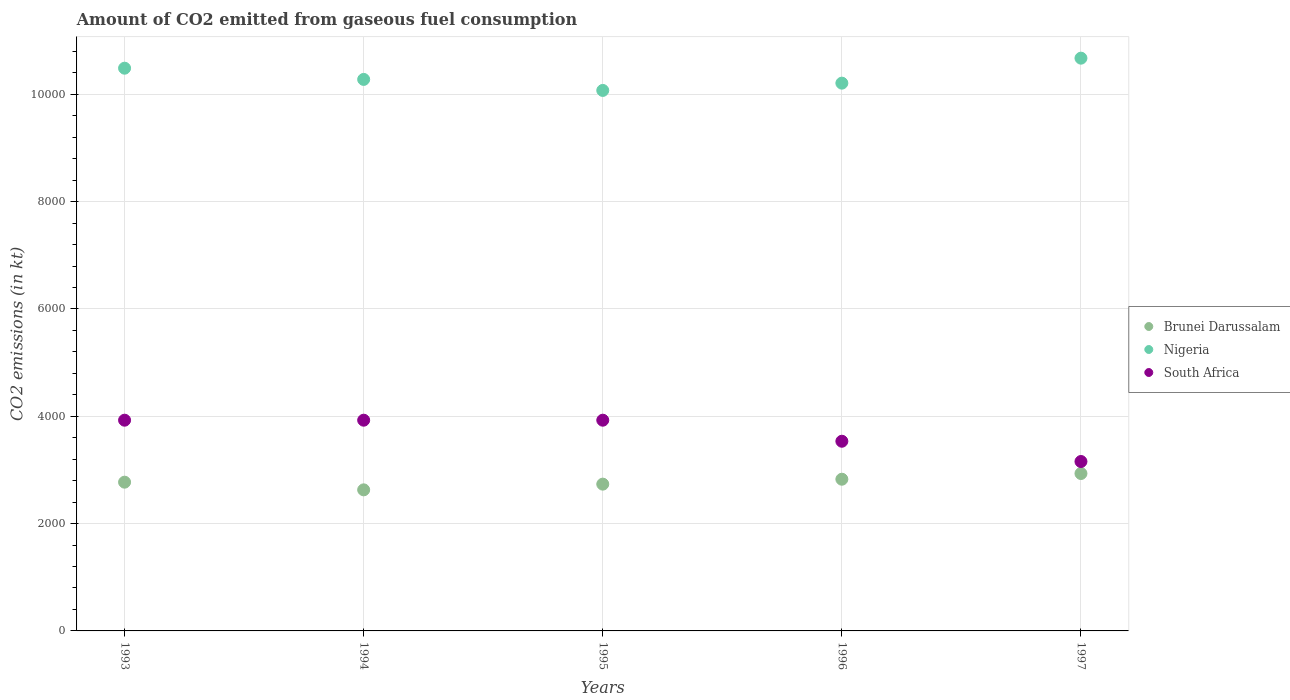How many different coloured dotlines are there?
Ensure brevity in your answer.  3. Is the number of dotlines equal to the number of legend labels?
Your answer should be compact. Yes. What is the amount of CO2 emitted in Nigeria in 1997?
Offer a very short reply. 1.07e+04. Across all years, what is the maximum amount of CO2 emitted in Nigeria?
Offer a very short reply. 1.07e+04. Across all years, what is the minimum amount of CO2 emitted in Nigeria?
Provide a succinct answer. 1.01e+04. What is the total amount of CO2 emitted in South Africa in the graph?
Offer a very short reply. 1.85e+04. What is the difference between the amount of CO2 emitted in South Africa in 1995 and that in 1997?
Make the answer very short. 770.07. What is the difference between the amount of CO2 emitted in Nigeria in 1994 and the amount of CO2 emitted in South Africa in 1996?
Your answer should be very brief. 6743.61. What is the average amount of CO2 emitted in South Africa per year?
Make the answer very short. 3694.87. In the year 1994, what is the difference between the amount of CO2 emitted in Nigeria and amount of CO2 emitted in South Africa?
Provide a succinct answer. 6351.24. What is the ratio of the amount of CO2 emitted in Brunei Darussalam in 1994 to that in 1996?
Offer a very short reply. 0.93. Is the difference between the amount of CO2 emitted in Nigeria in 1993 and 1996 greater than the difference between the amount of CO2 emitted in South Africa in 1993 and 1996?
Provide a succinct answer. No. What is the difference between the highest and the second highest amount of CO2 emitted in Nigeria?
Make the answer very short. 187.02. What is the difference between the highest and the lowest amount of CO2 emitted in Brunei Darussalam?
Ensure brevity in your answer.  304.36. In how many years, is the amount of CO2 emitted in Brunei Darussalam greater than the average amount of CO2 emitted in Brunei Darussalam taken over all years?
Your response must be concise. 2. Is the sum of the amount of CO2 emitted in South Africa in 1993 and 1994 greater than the maximum amount of CO2 emitted in Nigeria across all years?
Ensure brevity in your answer.  No. Does the amount of CO2 emitted in South Africa monotonically increase over the years?
Your answer should be compact. No. Is the amount of CO2 emitted in Brunei Darussalam strictly greater than the amount of CO2 emitted in Nigeria over the years?
Offer a very short reply. No. Is the amount of CO2 emitted in Brunei Darussalam strictly less than the amount of CO2 emitted in South Africa over the years?
Offer a terse response. Yes. How many dotlines are there?
Keep it short and to the point. 3. What is the difference between two consecutive major ticks on the Y-axis?
Offer a terse response. 2000. Are the values on the major ticks of Y-axis written in scientific E-notation?
Provide a succinct answer. No. Does the graph contain grids?
Offer a terse response. Yes. What is the title of the graph?
Keep it short and to the point. Amount of CO2 emitted from gaseous fuel consumption. What is the label or title of the Y-axis?
Your answer should be compact. CO2 emissions (in kt). What is the CO2 emissions (in kt) of Brunei Darussalam in 1993?
Your answer should be compact. 2772.25. What is the CO2 emissions (in kt) in Nigeria in 1993?
Your answer should be compact. 1.05e+04. What is the CO2 emissions (in kt) of South Africa in 1993?
Your answer should be very brief. 3927.36. What is the CO2 emissions (in kt) of Brunei Darussalam in 1994?
Provide a short and direct response. 2629.24. What is the CO2 emissions (in kt) in Nigeria in 1994?
Offer a very short reply. 1.03e+04. What is the CO2 emissions (in kt) in South Africa in 1994?
Your response must be concise. 3927.36. What is the CO2 emissions (in kt) of Brunei Darussalam in 1995?
Make the answer very short. 2735.58. What is the CO2 emissions (in kt) of Nigeria in 1995?
Offer a very short reply. 1.01e+04. What is the CO2 emissions (in kt) of South Africa in 1995?
Provide a succinct answer. 3927.36. What is the CO2 emissions (in kt) of Brunei Darussalam in 1996?
Your answer should be very brief. 2827.26. What is the CO2 emissions (in kt) in Nigeria in 1996?
Keep it short and to the point. 1.02e+04. What is the CO2 emissions (in kt) in South Africa in 1996?
Offer a terse response. 3534.99. What is the CO2 emissions (in kt) in Brunei Darussalam in 1997?
Offer a terse response. 2933.6. What is the CO2 emissions (in kt) in Nigeria in 1997?
Make the answer very short. 1.07e+04. What is the CO2 emissions (in kt) of South Africa in 1997?
Give a very brief answer. 3157.29. Across all years, what is the maximum CO2 emissions (in kt) of Brunei Darussalam?
Your answer should be compact. 2933.6. Across all years, what is the maximum CO2 emissions (in kt) in Nigeria?
Offer a terse response. 1.07e+04. Across all years, what is the maximum CO2 emissions (in kt) in South Africa?
Keep it short and to the point. 3927.36. Across all years, what is the minimum CO2 emissions (in kt) of Brunei Darussalam?
Ensure brevity in your answer.  2629.24. Across all years, what is the minimum CO2 emissions (in kt) of Nigeria?
Your answer should be very brief. 1.01e+04. Across all years, what is the minimum CO2 emissions (in kt) of South Africa?
Provide a succinct answer. 3157.29. What is the total CO2 emissions (in kt) in Brunei Darussalam in the graph?
Offer a terse response. 1.39e+04. What is the total CO2 emissions (in kt) in Nigeria in the graph?
Offer a very short reply. 5.17e+04. What is the total CO2 emissions (in kt) of South Africa in the graph?
Provide a short and direct response. 1.85e+04. What is the difference between the CO2 emissions (in kt) in Brunei Darussalam in 1993 and that in 1994?
Ensure brevity in your answer.  143.01. What is the difference between the CO2 emissions (in kt) in Nigeria in 1993 and that in 1994?
Your answer should be compact. 209.02. What is the difference between the CO2 emissions (in kt) of Brunei Darussalam in 1993 and that in 1995?
Keep it short and to the point. 36.67. What is the difference between the CO2 emissions (in kt) in Nigeria in 1993 and that in 1995?
Your answer should be compact. 414.37. What is the difference between the CO2 emissions (in kt) in South Africa in 1993 and that in 1995?
Make the answer very short. 0. What is the difference between the CO2 emissions (in kt) of Brunei Darussalam in 1993 and that in 1996?
Ensure brevity in your answer.  -55.01. What is the difference between the CO2 emissions (in kt) in Nigeria in 1993 and that in 1996?
Provide a succinct answer. 278.69. What is the difference between the CO2 emissions (in kt) of South Africa in 1993 and that in 1996?
Provide a short and direct response. 392.37. What is the difference between the CO2 emissions (in kt) of Brunei Darussalam in 1993 and that in 1997?
Keep it short and to the point. -161.35. What is the difference between the CO2 emissions (in kt) of Nigeria in 1993 and that in 1997?
Your answer should be compact. -187.02. What is the difference between the CO2 emissions (in kt) in South Africa in 1993 and that in 1997?
Provide a succinct answer. 770.07. What is the difference between the CO2 emissions (in kt) of Brunei Darussalam in 1994 and that in 1995?
Your answer should be very brief. -106.34. What is the difference between the CO2 emissions (in kt) in Nigeria in 1994 and that in 1995?
Give a very brief answer. 205.35. What is the difference between the CO2 emissions (in kt) of Brunei Darussalam in 1994 and that in 1996?
Your answer should be compact. -198.02. What is the difference between the CO2 emissions (in kt) of Nigeria in 1994 and that in 1996?
Ensure brevity in your answer.  69.67. What is the difference between the CO2 emissions (in kt) in South Africa in 1994 and that in 1996?
Make the answer very short. 392.37. What is the difference between the CO2 emissions (in kt) of Brunei Darussalam in 1994 and that in 1997?
Provide a short and direct response. -304.36. What is the difference between the CO2 emissions (in kt) in Nigeria in 1994 and that in 1997?
Ensure brevity in your answer.  -396.04. What is the difference between the CO2 emissions (in kt) of South Africa in 1994 and that in 1997?
Provide a short and direct response. 770.07. What is the difference between the CO2 emissions (in kt) in Brunei Darussalam in 1995 and that in 1996?
Give a very brief answer. -91.67. What is the difference between the CO2 emissions (in kt) in Nigeria in 1995 and that in 1996?
Offer a very short reply. -135.68. What is the difference between the CO2 emissions (in kt) of South Africa in 1995 and that in 1996?
Give a very brief answer. 392.37. What is the difference between the CO2 emissions (in kt) of Brunei Darussalam in 1995 and that in 1997?
Provide a short and direct response. -198.02. What is the difference between the CO2 emissions (in kt) of Nigeria in 1995 and that in 1997?
Offer a very short reply. -601.39. What is the difference between the CO2 emissions (in kt) in South Africa in 1995 and that in 1997?
Provide a short and direct response. 770.07. What is the difference between the CO2 emissions (in kt) of Brunei Darussalam in 1996 and that in 1997?
Provide a short and direct response. -106.34. What is the difference between the CO2 emissions (in kt) of Nigeria in 1996 and that in 1997?
Offer a very short reply. -465.71. What is the difference between the CO2 emissions (in kt) in South Africa in 1996 and that in 1997?
Your answer should be compact. 377.7. What is the difference between the CO2 emissions (in kt) in Brunei Darussalam in 1993 and the CO2 emissions (in kt) in Nigeria in 1994?
Your answer should be compact. -7506.35. What is the difference between the CO2 emissions (in kt) in Brunei Darussalam in 1993 and the CO2 emissions (in kt) in South Africa in 1994?
Give a very brief answer. -1155.11. What is the difference between the CO2 emissions (in kt) in Nigeria in 1993 and the CO2 emissions (in kt) in South Africa in 1994?
Offer a terse response. 6560.26. What is the difference between the CO2 emissions (in kt) in Brunei Darussalam in 1993 and the CO2 emissions (in kt) in Nigeria in 1995?
Make the answer very short. -7301. What is the difference between the CO2 emissions (in kt) of Brunei Darussalam in 1993 and the CO2 emissions (in kt) of South Africa in 1995?
Provide a short and direct response. -1155.11. What is the difference between the CO2 emissions (in kt) in Nigeria in 1993 and the CO2 emissions (in kt) in South Africa in 1995?
Ensure brevity in your answer.  6560.26. What is the difference between the CO2 emissions (in kt) of Brunei Darussalam in 1993 and the CO2 emissions (in kt) of Nigeria in 1996?
Your answer should be very brief. -7436.68. What is the difference between the CO2 emissions (in kt) of Brunei Darussalam in 1993 and the CO2 emissions (in kt) of South Africa in 1996?
Offer a terse response. -762.74. What is the difference between the CO2 emissions (in kt) of Nigeria in 1993 and the CO2 emissions (in kt) of South Africa in 1996?
Make the answer very short. 6952.63. What is the difference between the CO2 emissions (in kt) in Brunei Darussalam in 1993 and the CO2 emissions (in kt) in Nigeria in 1997?
Your answer should be compact. -7902.39. What is the difference between the CO2 emissions (in kt) in Brunei Darussalam in 1993 and the CO2 emissions (in kt) in South Africa in 1997?
Give a very brief answer. -385.04. What is the difference between the CO2 emissions (in kt) in Nigeria in 1993 and the CO2 emissions (in kt) in South Africa in 1997?
Provide a succinct answer. 7330.33. What is the difference between the CO2 emissions (in kt) in Brunei Darussalam in 1994 and the CO2 emissions (in kt) in Nigeria in 1995?
Provide a short and direct response. -7444.01. What is the difference between the CO2 emissions (in kt) in Brunei Darussalam in 1994 and the CO2 emissions (in kt) in South Africa in 1995?
Your response must be concise. -1298.12. What is the difference between the CO2 emissions (in kt) in Nigeria in 1994 and the CO2 emissions (in kt) in South Africa in 1995?
Keep it short and to the point. 6351.24. What is the difference between the CO2 emissions (in kt) of Brunei Darussalam in 1994 and the CO2 emissions (in kt) of Nigeria in 1996?
Your response must be concise. -7579.69. What is the difference between the CO2 emissions (in kt) in Brunei Darussalam in 1994 and the CO2 emissions (in kt) in South Africa in 1996?
Keep it short and to the point. -905.75. What is the difference between the CO2 emissions (in kt) in Nigeria in 1994 and the CO2 emissions (in kt) in South Africa in 1996?
Keep it short and to the point. 6743.61. What is the difference between the CO2 emissions (in kt) of Brunei Darussalam in 1994 and the CO2 emissions (in kt) of Nigeria in 1997?
Provide a short and direct response. -8045.4. What is the difference between the CO2 emissions (in kt) of Brunei Darussalam in 1994 and the CO2 emissions (in kt) of South Africa in 1997?
Keep it short and to the point. -528.05. What is the difference between the CO2 emissions (in kt) of Nigeria in 1994 and the CO2 emissions (in kt) of South Africa in 1997?
Provide a succinct answer. 7121.31. What is the difference between the CO2 emissions (in kt) of Brunei Darussalam in 1995 and the CO2 emissions (in kt) of Nigeria in 1996?
Offer a very short reply. -7473.35. What is the difference between the CO2 emissions (in kt) of Brunei Darussalam in 1995 and the CO2 emissions (in kt) of South Africa in 1996?
Ensure brevity in your answer.  -799.41. What is the difference between the CO2 emissions (in kt) in Nigeria in 1995 and the CO2 emissions (in kt) in South Africa in 1996?
Give a very brief answer. 6538.26. What is the difference between the CO2 emissions (in kt) of Brunei Darussalam in 1995 and the CO2 emissions (in kt) of Nigeria in 1997?
Offer a terse response. -7939.06. What is the difference between the CO2 emissions (in kt) in Brunei Darussalam in 1995 and the CO2 emissions (in kt) in South Africa in 1997?
Your response must be concise. -421.7. What is the difference between the CO2 emissions (in kt) in Nigeria in 1995 and the CO2 emissions (in kt) in South Africa in 1997?
Your response must be concise. 6915.96. What is the difference between the CO2 emissions (in kt) of Brunei Darussalam in 1996 and the CO2 emissions (in kt) of Nigeria in 1997?
Keep it short and to the point. -7847.38. What is the difference between the CO2 emissions (in kt) in Brunei Darussalam in 1996 and the CO2 emissions (in kt) in South Africa in 1997?
Offer a terse response. -330.03. What is the difference between the CO2 emissions (in kt) in Nigeria in 1996 and the CO2 emissions (in kt) in South Africa in 1997?
Provide a succinct answer. 7051.64. What is the average CO2 emissions (in kt) of Brunei Darussalam per year?
Make the answer very short. 2779.59. What is the average CO2 emissions (in kt) in Nigeria per year?
Your answer should be very brief. 1.03e+04. What is the average CO2 emissions (in kt) in South Africa per year?
Your answer should be very brief. 3694.87. In the year 1993, what is the difference between the CO2 emissions (in kt) in Brunei Darussalam and CO2 emissions (in kt) in Nigeria?
Keep it short and to the point. -7715.37. In the year 1993, what is the difference between the CO2 emissions (in kt) of Brunei Darussalam and CO2 emissions (in kt) of South Africa?
Offer a very short reply. -1155.11. In the year 1993, what is the difference between the CO2 emissions (in kt) of Nigeria and CO2 emissions (in kt) of South Africa?
Your response must be concise. 6560.26. In the year 1994, what is the difference between the CO2 emissions (in kt) in Brunei Darussalam and CO2 emissions (in kt) in Nigeria?
Your response must be concise. -7649.36. In the year 1994, what is the difference between the CO2 emissions (in kt) in Brunei Darussalam and CO2 emissions (in kt) in South Africa?
Offer a very short reply. -1298.12. In the year 1994, what is the difference between the CO2 emissions (in kt) of Nigeria and CO2 emissions (in kt) of South Africa?
Provide a succinct answer. 6351.24. In the year 1995, what is the difference between the CO2 emissions (in kt) in Brunei Darussalam and CO2 emissions (in kt) in Nigeria?
Your response must be concise. -7337.67. In the year 1995, what is the difference between the CO2 emissions (in kt) in Brunei Darussalam and CO2 emissions (in kt) in South Africa?
Offer a terse response. -1191.78. In the year 1995, what is the difference between the CO2 emissions (in kt) of Nigeria and CO2 emissions (in kt) of South Africa?
Give a very brief answer. 6145.89. In the year 1996, what is the difference between the CO2 emissions (in kt) of Brunei Darussalam and CO2 emissions (in kt) of Nigeria?
Keep it short and to the point. -7381.67. In the year 1996, what is the difference between the CO2 emissions (in kt) in Brunei Darussalam and CO2 emissions (in kt) in South Africa?
Your answer should be very brief. -707.73. In the year 1996, what is the difference between the CO2 emissions (in kt) in Nigeria and CO2 emissions (in kt) in South Africa?
Your answer should be compact. 6673.94. In the year 1997, what is the difference between the CO2 emissions (in kt) of Brunei Darussalam and CO2 emissions (in kt) of Nigeria?
Provide a short and direct response. -7741.04. In the year 1997, what is the difference between the CO2 emissions (in kt) in Brunei Darussalam and CO2 emissions (in kt) in South Africa?
Your answer should be very brief. -223.69. In the year 1997, what is the difference between the CO2 emissions (in kt) in Nigeria and CO2 emissions (in kt) in South Africa?
Give a very brief answer. 7517.35. What is the ratio of the CO2 emissions (in kt) in Brunei Darussalam in 1993 to that in 1994?
Provide a short and direct response. 1.05. What is the ratio of the CO2 emissions (in kt) of Nigeria in 1993 to that in 1994?
Offer a terse response. 1.02. What is the ratio of the CO2 emissions (in kt) in South Africa in 1993 to that in 1994?
Your answer should be compact. 1. What is the ratio of the CO2 emissions (in kt) of Brunei Darussalam in 1993 to that in 1995?
Offer a terse response. 1.01. What is the ratio of the CO2 emissions (in kt) of Nigeria in 1993 to that in 1995?
Give a very brief answer. 1.04. What is the ratio of the CO2 emissions (in kt) of Brunei Darussalam in 1993 to that in 1996?
Your answer should be very brief. 0.98. What is the ratio of the CO2 emissions (in kt) of Nigeria in 1993 to that in 1996?
Give a very brief answer. 1.03. What is the ratio of the CO2 emissions (in kt) of South Africa in 1993 to that in 1996?
Your answer should be compact. 1.11. What is the ratio of the CO2 emissions (in kt) of Brunei Darussalam in 1993 to that in 1997?
Ensure brevity in your answer.  0.94. What is the ratio of the CO2 emissions (in kt) in Nigeria in 1993 to that in 1997?
Your answer should be compact. 0.98. What is the ratio of the CO2 emissions (in kt) in South Africa in 1993 to that in 1997?
Ensure brevity in your answer.  1.24. What is the ratio of the CO2 emissions (in kt) of Brunei Darussalam in 1994 to that in 1995?
Your response must be concise. 0.96. What is the ratio of the CO2 emissions (in kt) of Nigeria in 1994 to that in 1995?
Provide a short and direct response. 1.02. What is the ratio of the CO2 emissions (in kt) of Nigeria in 1994 to that in 1996?
Your answer should be compact. 1.01. What is the ratio of the CO2 emissions (in kt) of South Africa in 1994 to that in 1996?
Your answer should be compact. 1.11. What is the ratio of the CO2 emissions (in kt) in Brunei Darussalam in 1994 to that in 1997?
Your answer should be very brief. 0.9. What is the ratio of the CO2 emissions (in kt) of Nigeria in 1994 to that in 1997?
Your answer should be very brief. 0.96. What is the ratio of the CO2 emissions (in kt) in South Africa in 1994 to that in 1997?
Ensure brevity in your answer.  1.24. What is the ratio of the CO2 emissions (in kt) of Brunei Darussalam in 1995 to that in 1996?
Your response must be concise. 0.97. What is the ratio of the CO2 emissions (in kt) in Nigeria in 1995 to that in 1996?
Keep it short and to the point. 0.99. What is the ratio of the CO2 emissions (in kt) of South Africa in 1995 to that in 1996?
Make the answer very short. 1.11. What is the ratio of the CO2 emissions (in kt) of Brunei Darussalam in 1995 to that in 1997?
Give a very brief answer. 0.93. What is the ratio of the CO2 emissions (in kt) in Nigeria in 1995 to that in 1997?
Your response must be concise. 0.94. What is the ratio of the CO2 emissions (in kt) of South Africa in 1995 to that in 1997?
Your answer should be compact. 1.24. What is the ratio of the CO2 emissions (in kt) in Brunei Darussalam in 1996 to that in 1997?
Keep it short and to the point. 0.96. What is the ratio of the CO2 emissions (in kt) of Nigeria in 1996 to that in 1997?
Offer a terse response. 0.96. What is the ratio of the CO2 emissions (in kt) in South Africa in 1996 to that in 1997?
Your answer should be compact. 1.12. What is the difference between the highest and the second highest CO2 emissions (in kt) in Brunei Darussalam?
Keep it short and to the point. 106.34. What is the difference between the highest and the second highest CO2 emissions (in kt) of Nigeria?
Your answer should be compact. 187.02. What is the difference between the highest and the second highest CO2 emissions (in kt) of South Africa?
Your response must be concise. 0. What is the difference between the highest and the lowest CO2 emissions (in kt) in Brunei Darussalam?
Offer a terse response. 304.36. What is the difference between the highest and the lowest CO2 emissions (in kt) in Nigeria?
Give a very brief answer. 601.39. What is the difference between the highest and the lowest CO2 emissions (in kt) of South Africa?
Offer a very short reply. 770.07. 